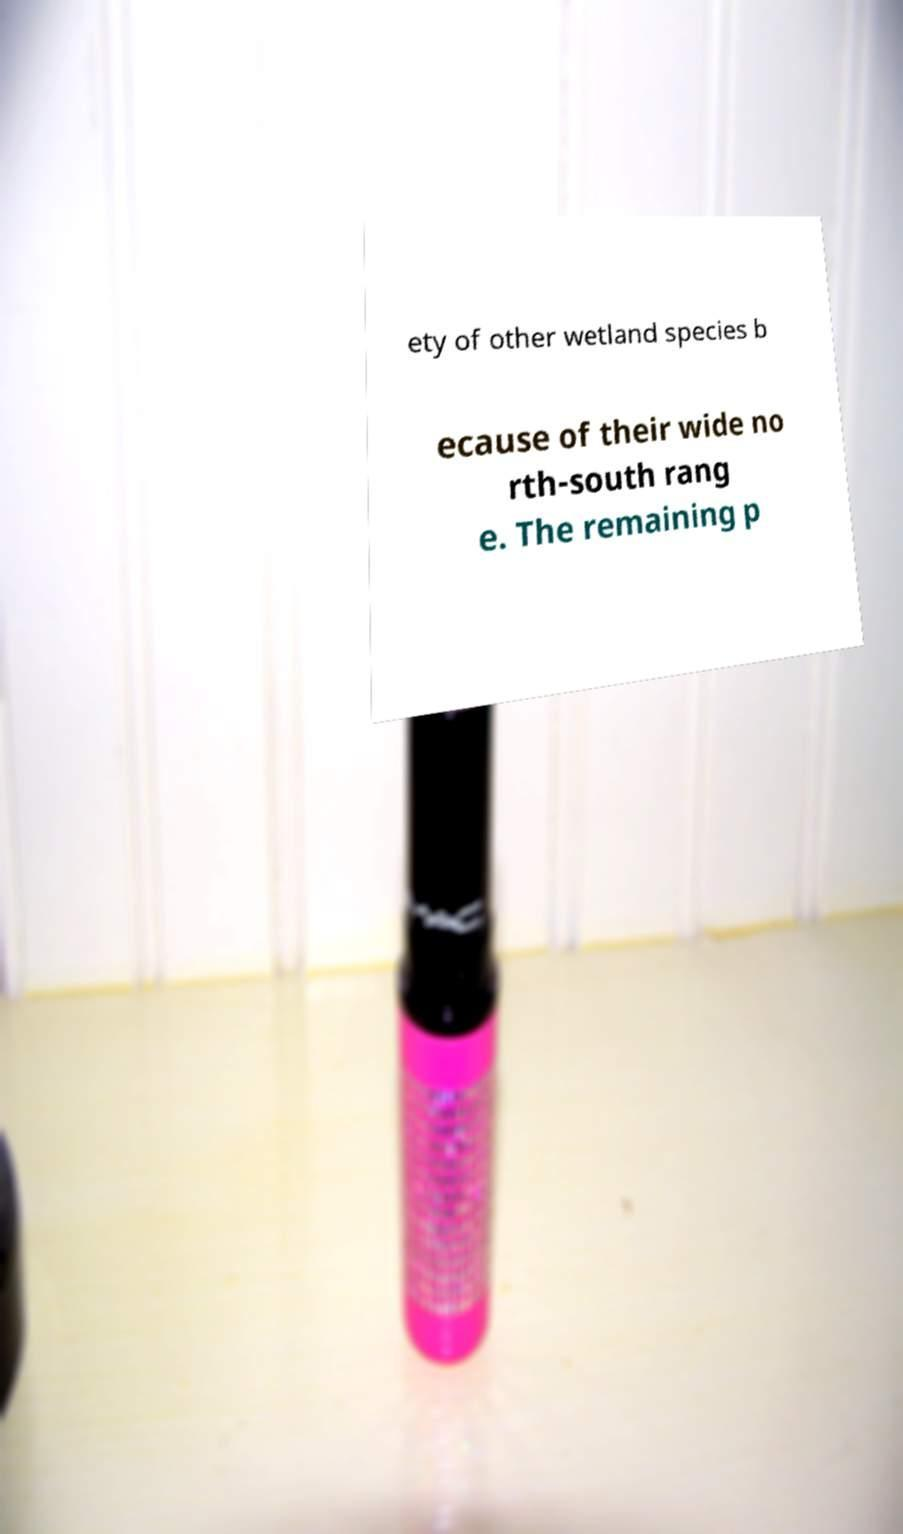Can you accurately transcribe the text from the provided image for me? ety of other wetland species b ecause of their wide no rth-south rang e. The remaining p 